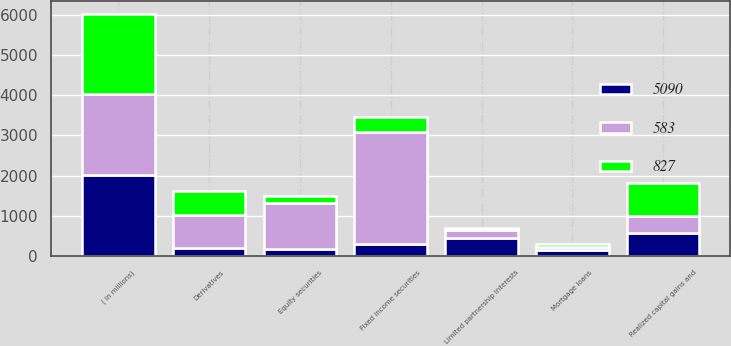Convert chart to OTSL. <chart><loc_0><loc_0><loc_500><loc_500><stacked_bar_chart><ecel><fcel>( in millions)<fcel>Fixed income securities<fcel>Equity securities<fcel>Mortgage loans<fcel>Limited partnership interests<fcel>Derivatives<fcel>Realized capital gains and<nl><fcel>827<fcel>2010<fcel>366<fcel>153<fcel>71<fcel>57<fcel>600<fcel>827<nl><fcel>5090<fcel>2009<fcel>302<fcel>181<fcel>144<fcel>446<fcel>206<fcel>583<nl><fcel>583<fcel>2008<fcel>2781<fcel>1149<fcel>94<fcel>194<fcel>821<fcel>406<nl></chart> 